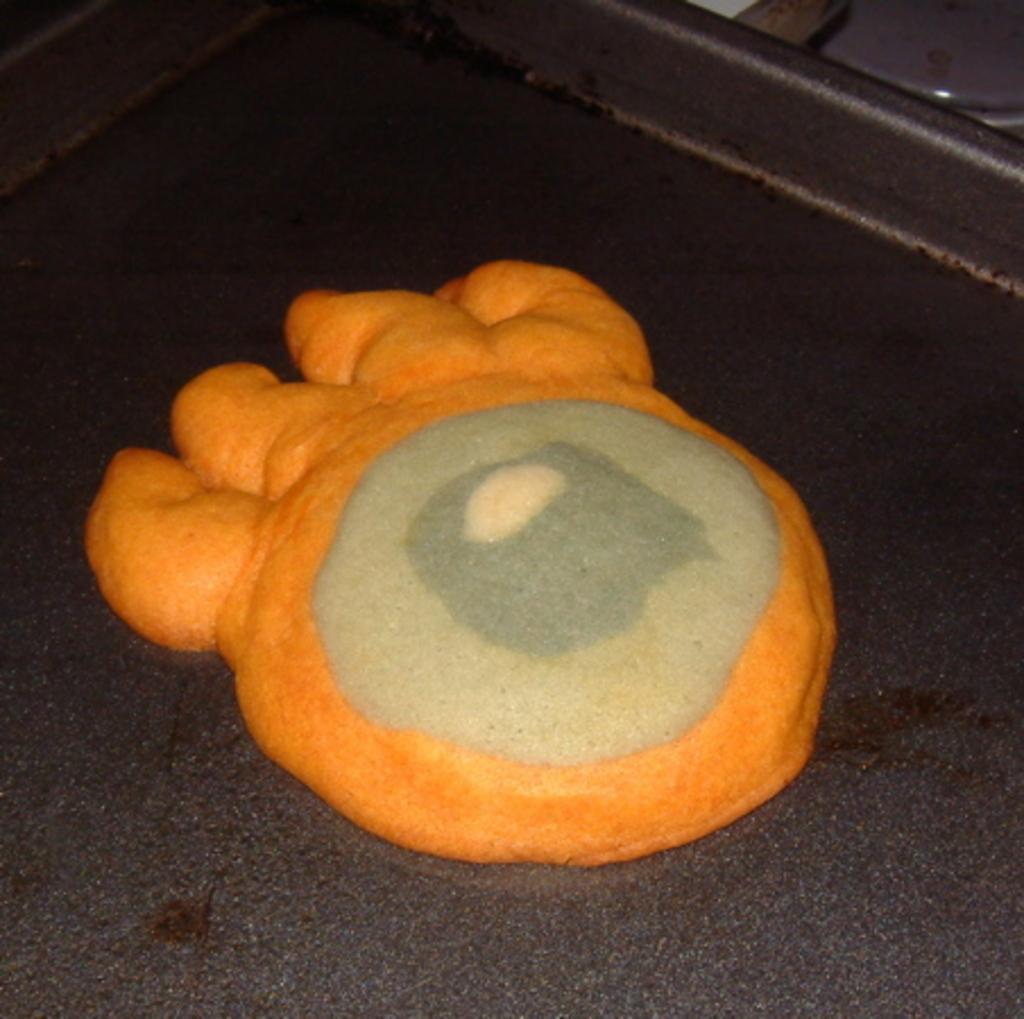In one or two sentences, can you explain what this image depicts? In the center of the image we can see one table. On the table,we can see one object,which is in orange and cream color. On the top right side of the image,we can see some object. 